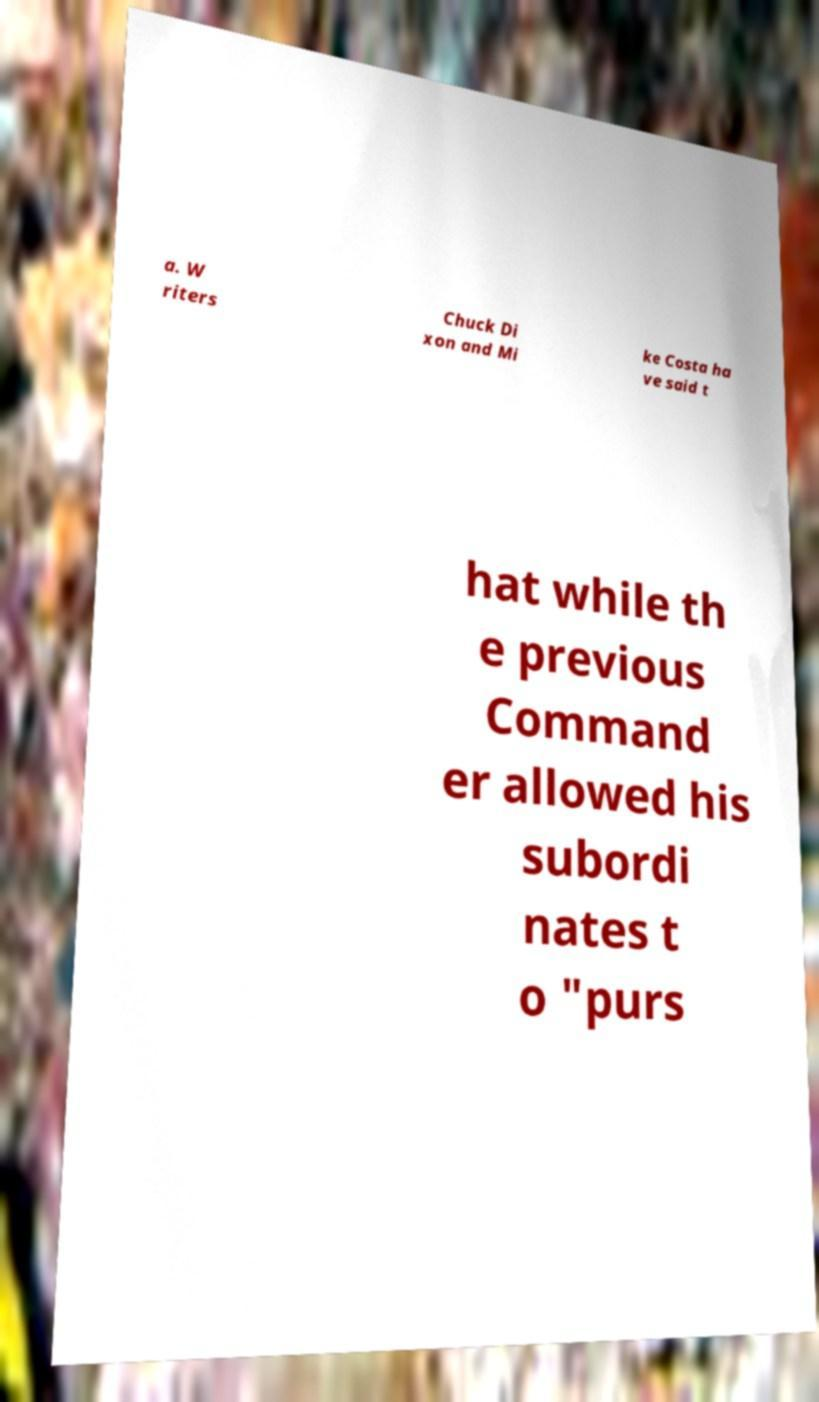Please identify and transcribe the text found in this image. a. W riters Chuck Di xon and Mi ke Costa ha ve said t hat while th e previous Command er allowed his subordi nates t o "purs 